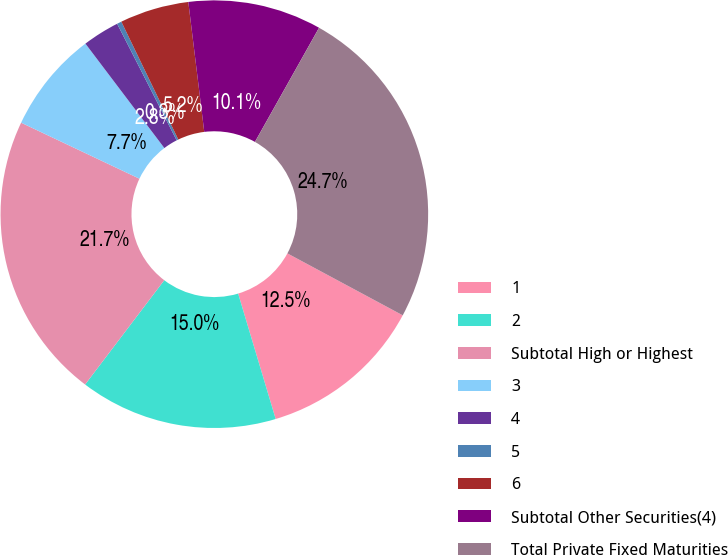Convert chart. <chart><loc_0><loc_0><loc_500><loc_500><pie_chart><fcel>1<fcel>2<fcel>Subtotal High or Highest<fcel>3<fcel>4<fcel>5<fcel>6<fcel>Subtotal Other Securities(4)<fcel>Total Private Fixed Maturities<nl><fcel>12.53%<fcel>14.96%<fcel>21.71%<fcel>7.66%<fcel>2.79%<fcel>0.35%<fcel>5.22%<fcel>10.09%<fcel>24.7%<nl></chart> 